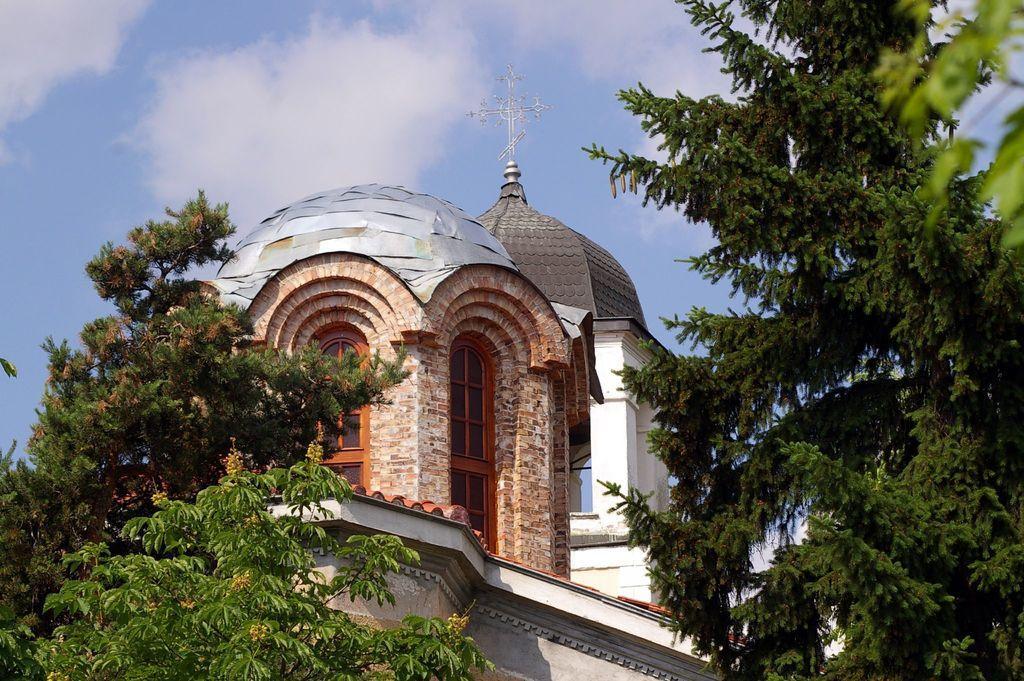Can you describe this image briefly? Here in this picture we can see a church building present with windows on it and Christianity symbol at the top of it over there and we can see trees present on either side of it and we can see clouds in the sky over there. 